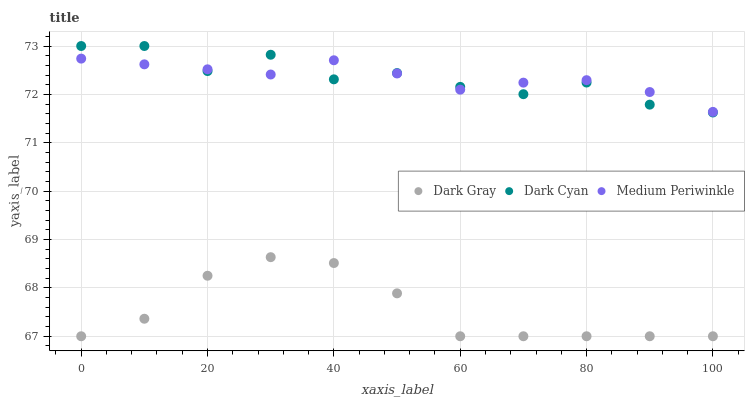Does Dark Gray have the minimum area under the curve?
Answer yes or no. Yes. Does Medium Periwinkle have the maximum area under the curve?
Answer yes or no. Yes. Does Dark Cyan have the minimum area under the curve?
Answer yes or no. No. Does Dark Cyan have the maximum area under the curve?
Answer yes or no. No. Is Medium Periwinkle the smoothest?
Answer yes or no. Yes. Is Dark Cyan the roughest?
Answer yes or no. Yes. Is Dark Cyan the smoothest?
Answer yes or no. No. Is Medium Periwinkle the roughest?
Answer yes or no. No. Does Dark Gray have the lowest value?
Answer yes or no. Yes. Does Dark Cyan have the lowest value?
Answer yes or no. No. Does Dark Cyan have the highest value?
Answer yes or no. Yes. Does Medium Periwinkle have the highest value?
Answer yes or no. No. Is Dark Gray less than Medium Periwinkle?
Answer yes or no. Yes. Is Dark Cyan greater than Dark Gray?
Answer yes or no. Yes. Does Medium Periwinkle intersect Dark Cyan?
Answer yes or no. Yes. Is Medium Periwinkle less than Dark Cyan?
Answer yes or no. No. Is Medium Periwinkle greater than Dark Cyan?
Answer yes or no. No. Does Dark Gray intersect Medium Periwinkle?
Answer yes or no. No. 